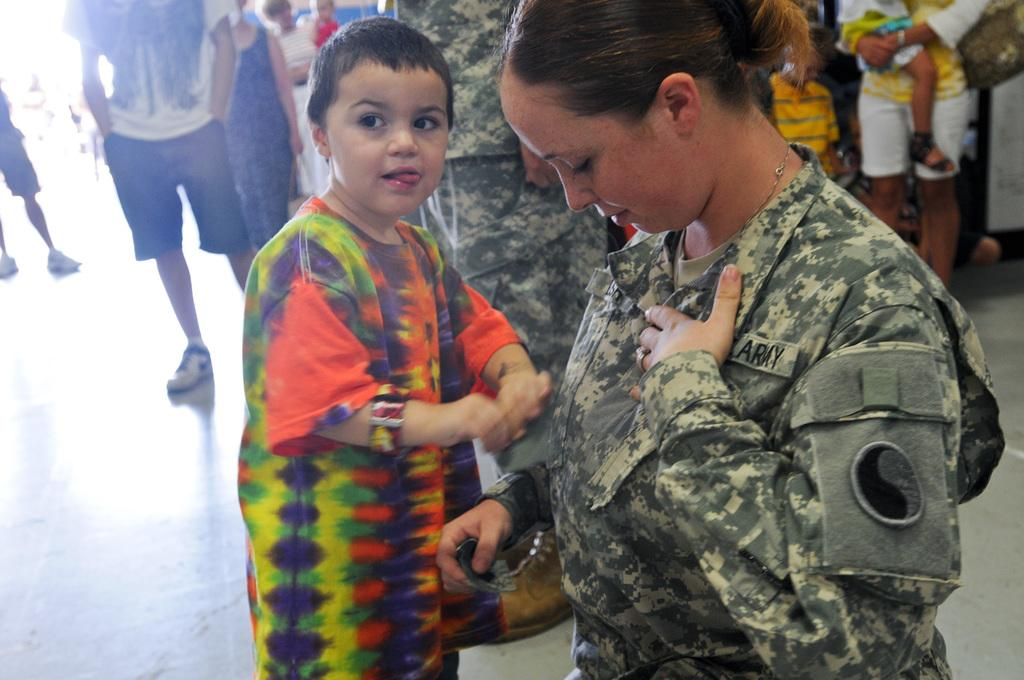Who or what is present in the image? There are people in the image. What are the people doing in the image? The people are standing on the floor. How many cats are sitting on the curtain in the image? There are no cats or curtains present in the image. 